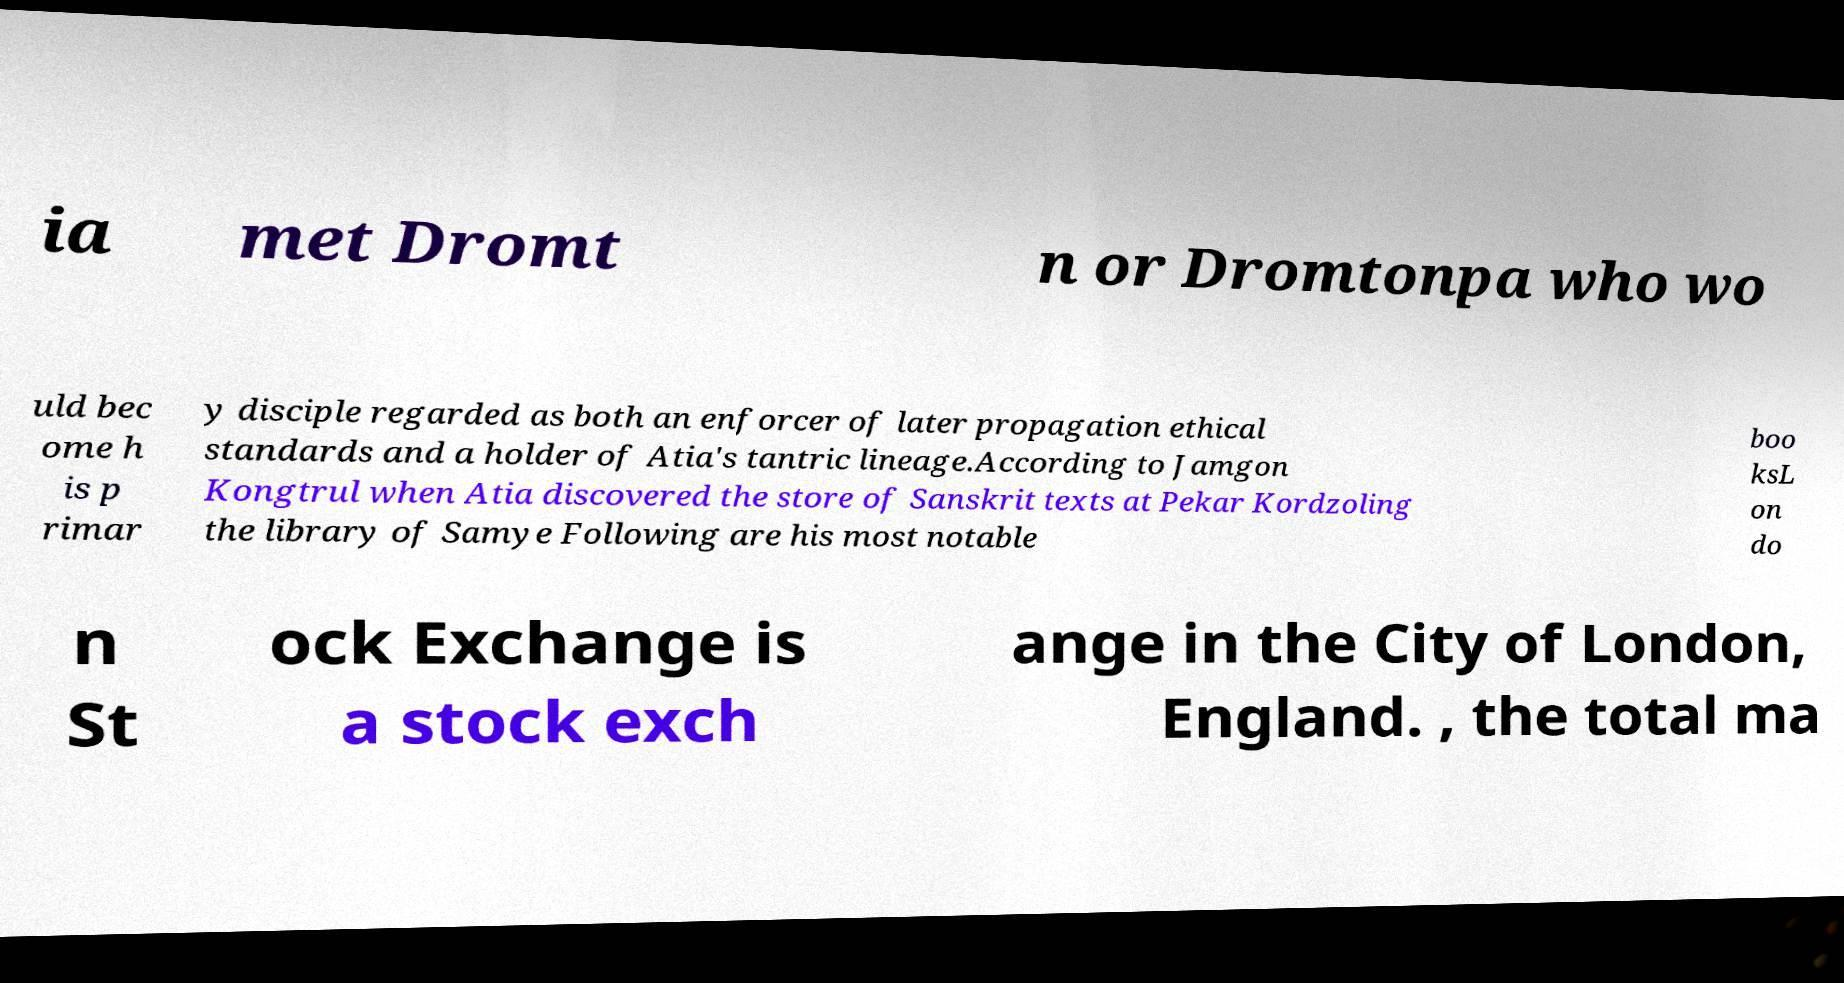I need the written content from this picture converted into text. Can you do that? ia met Dromt n or Dromtonpa who wo uld bec ome h is p rimar y disciple regarded as both an enforcer of later propagation ethical standards and a holder of Atia's tantric lineage.According to Jamgon Kongtrul when Atia discovered the store of Sanskrit texts at Pekar Kordzoling the library of Samye Following are his most notable boo ksL on do n St ock Exchange is a stock exch ange in the City of London, England. , the total ma 